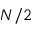Convert formula to latex. <formula><loc_0><loc_0><loc_500><loc_500>N / 2</formula> 